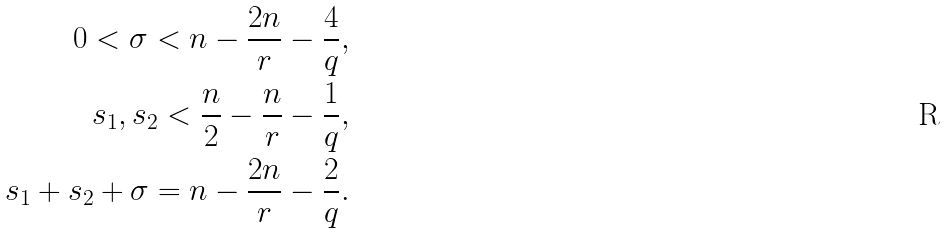<formula> <loc_0><loc_0><loc_500><loc_500>0 < \sigma < n - \frac { 2 n } { r } - \frac { 4 } { q } , \\ s _ { 1 } , s _ { 2 } < \frac { n } { 2 } - \frac { n } { r } - \frac { 1 } { q } , \\ s _ { 1 } + s _ { 2 } + \sigma = n - \frac { 2 n } { r } - \frac { 2 } { q } .</formula> 